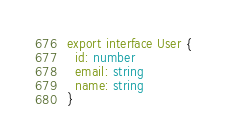Convert code to text. <code><loc_0><loc_0><loc_500><loc_500><_TypeScript_>export interface User {
  id: number
  email: string
  name: string
}
</code> 